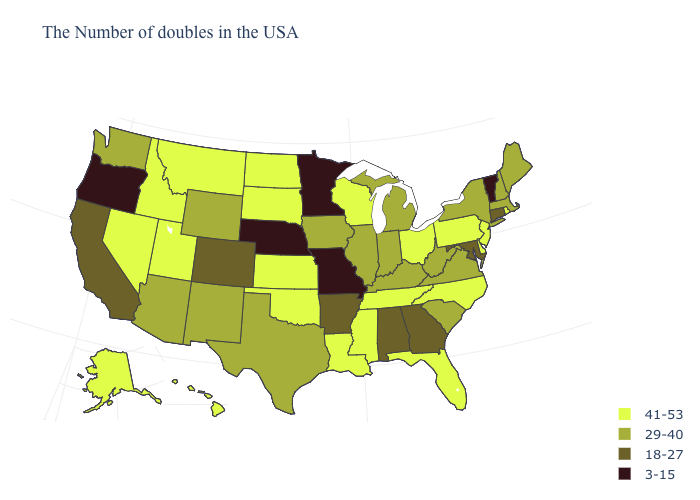Among the states that border Vermont , which have the highest value?
Keep it brief. Massachusetts, New Hampshire, New York. What is the value of Utah?
Short answer required. 41-53. Name the states that have a value in the range 29-40?
Give a very brief answer. Maine, Massachusetts, New Hampshire, New York, Virginia, South Carolina, West Virginia, Michigan, Kentucky, Indiana, Illinois, Iowa, Texas, Wyoming, New Mexico, Arizona, Washington. What is the highest value in the MidWest ?
Quick response, please. 41-53. Which states have the lowest value in the MidWest?
Be succinct. Missouri, Minnesota, Nebraska. Does Delaware have the highest value in the South?
Answer briefly. Yes. What is the lowest value in the USA?
Be succinct. 3-15. What is the lowest value in the USA?
Be succinct. 3-15. Name the states that have a value in the range 29-40?
Concise answer only. Maine, Massachusetts, New Hampshire, New York, Virginia, South Carolina, West Virginia, Michigan, Kentucky, Indiana, Illinois, Iowa, Texas, Wyoming, New Mexico, Arizona, Washington. Name the states that have a value in the range 29-40?
Give a very brief answer. Maine, Massachusetts, New Hampshire, New York, Virginia, South Carolina, West Virginia, Michigan, Kentucky, Indiana, Illinois, Iowa, Texas, Wyoming, New Mexico, Arizona, Washington. What is the highest value in the USA?
Keep it brief. 41-53. What is the value of Ohio?
Write a very short answer. 41-53. Among the states that border New York , which have the highest value?
Quick response, please. New Jersey, Pennsylvania. Which states have the lowest value in the Northeast?
Answer briefly. Vermont. Which states have the highest value in the USA?
Short answer required. Rhode Island, New Jersey, Delaware, Pennsylvania, North Carolina, Ohio, Florida, Tennessee, Wisconsin, Mississippi, Louisiana, Kansas, Oklahoma, South Dakota, North Dakota, Utah, Montana, Idaho, Nevada, Alaska, Hawaii. 